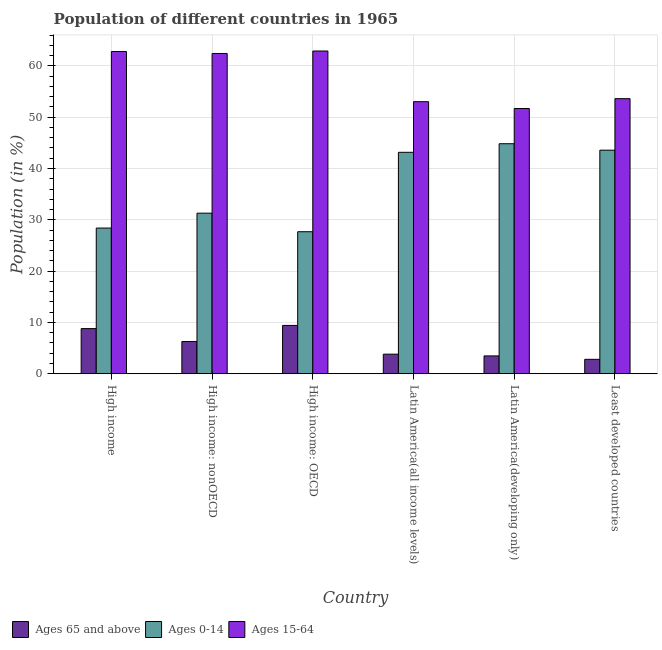How many different coloured bars are there?
Your answer should be compact. 3. Are the number of bars per tick equal to the number of legend labels?
Ensure brevity in your answer.  Yes. How many bars are there on the 6th tick from the left?
Ensure brevity in your answer.  3. What is the label of the 3rd group of bars from the left?
Your answer should be very brief. High income: OECD. In how many cases, is the number of bars for a given country not equal to the number of legend labels?
Keep it short and to the point. 0. What is the percentage of population within the age-group 0-14 in Latin America(all income levels)?
Give a very brief answer. 43.16. Across all countries, what is the maximum percentage of population within the age-group 0-14?
Provide a short and direct response. 44.83. Across all countries, what is the minimum percentage of population within the age-group 0-14?
Ensure brevity in your answer.  27.68. In which country was the percentage of population within the age-group 0-14 maximum?
Give a very brief answer. Latin America(developing only). In which country was the percentage of population within the age-group 0-14 minimum?
Your answer should be compact. High income: OECD. What is the total percentage of population within the age-group 0-14 in the graph?
Your answer should be compact. 218.94. What is the difference between the percentage of population within the age-group 0-14 in High income: OECD and that in High income: nonOECD?
Give a very brief answer. -3.62. What is the difference between the percentage of population within the age-group 0-14 in Latin America(developing only) and the percentage of population within the age-group 15-64 in High income?
Your answer should be compact. -17.98. What is the average percentage of population within the age-group 0-14 per country?
Offer a very short reply. 36.49. What is the difference between the percentage of population within the age-group 0-14 and percentage of population within the age-group of 65 and above in High income?
Ensure brevity in your answer.  19.6. What is the ratio of the percentage of population within the age-group of 65 and above in High income to that in Least developed countries?
Offer a very short reply. 3.13. Is the percentage of population within the age-group 15-64 in High income: OECD less than that in High income: nonOECD?
Provide a succinct answer. No. What is the difference between the highest and the second highest percentage of population within the age-group of 65 and above?
Make the answer very short. 0.62. What is the difference between the highest and the lowest percentage of population within the age-group 15-64?
Keep it short and to the point. 11.21. Is the sum of the percentage of population within the age-group of 65 and above in High income: OECD and Latin America(all income levels) greater than the maximum percentage of population within the age-group 0-14 across all countries?
Provide a short and direct response. No. What does the 3rd bar from the left in High income: OECD represents?
Offer a very short reply. Ages 15-64. What does the 2nd bar from the right in Latin America(developing only) represents?
Make the answer very short. Ages 0-14. How many bars are there?
Give a very brief answer. 18. Are all the bars in the graph horizontal?
Your answer should be compact. No. How many countries are there in the graph?
Offer a very short reply. 6. What is the difference between two consecutive major ticks on the Y-axis?
Offer a terse response. 10. Does the graph contain grids?
Ensure brevity in your answer.  Yes. How many legend labels are there?
Provide a short and direct response. 3. What is the title of the graph?
Make the answer very short. Population of different countries in 1965. What is the label or title of the X-axis?
Your answer should be compact. Country. What is the Population (in %) in Ages 65 and above in High income?
Give a very brief answer. 8.8. What is the Population (in %) in Ages 0-14 in High income?
Provide a short and direct response. 28.4. What is the Population (in %) in Ages 15-64 in High income?
Keep it short and to the point. 62.81. What is the Population (in %) of Ages 65 and above in High income: nonOECD?
Keep it short and to the point. 6.28. What is the Population (in %) in Ages 0-14 in High income: nonOECD?
Your answer should be very brief. 31.3. What is the Population (in %) in Ages 15-64 in High income: nonOECD?
Give a very brief answer. 62.42. What is the Population (in %) of Ages 65 and above in High income: OECD?
Keep it short and to the point. 9.42. What is the Population (in %) in Ages 0-14 in High income: OECD?
Your response must be concise. 27.68. What is the Population (in %) in Ages 15-64 in High income: OECD?
Offer a very short reply. 62.9. What is the Population (in %) in Ages 65 and above in Latin America(all income levels)?
Your answer should be very brief. 3.82. What is the Population (in %) of Ages 0-14 in Latin America(all income levels)?
Offer a terse response. 43.16. What is the Population (in %) of Ages 15-64 in Latin America(all income levels)?
Give a very brief answer. 53.03. What is the Population (in %) of Ages 65 and above in Latin America(developing only)?
Offer a terse response. 3.47. What is the Population (in %) in Ages 0-14 in Latin America(developing only)?
Offer a terse response. 44.83. What is the Population (in %) of Ages 15-64 in Latin America(developing only)?
Provide a succinct answer. 51.7. What is the Population (in %) in Ages 65 and above in Least developed countries?
Provide a succinct answer. 2.81. What is the Population (in %) of Ages 0-14 in Least developed countries?
Provide a succinct answer. 43.57. What is the Population (in %) of Ages 15-64 in Least developed countries?
Offer a terse response. 53.61. Across all countries, what is the maximum Population (in %) of Ages 65 and above?
Your answer should be very brief. 9.42. Across all countries, what is the maximum Population (in %) of Ages 0-14?
Give a very brief answer. 44.83. Across all countries, what is the maximum Population (in %) of Ages 15-64?
Provide a succinct answer. 62.9. Across all countries, what is the minimum Population (in %) of Ages 65 and above?
Keep it short and to the point. 2.81. Across all countries, what is the minimum Population (in %) in Ages 0-14?
Make the answer very short. 27.68. Across all countries, what is the minimum Population (in %) of Ages 15-64?
Your answer should be compact. 51.7. What is the total Population (in %) of Ages 65 and above in the graph?
Make the answer very short. 34.6. What is the total Population (in %) in Ages 0-14 in the graph?
Your answer should be very brief. 218.94. What is the total Population (in %) in Ages 15-64 in the graph?
Your answer should be compact. 346.47. What is the difference between the Population (in %) of Ages 65 and above in High income and that in High income: nonOECD?
Your response must be concise. 2.52. What is the difference between the Population (in %) in Ages 0-14 in High income and that in High income: nonOECD?
Offer a very short reply. -2.9. What is the difference between the Population (in %) of Ages 15-64 in High income and that in High income: nonOECD?
Offer a very short reply. 0.39. What is the difference between the Population (in %) of Ages 65 and above in High income and that in High income: OECD?
Give a very brief answer. -0.62. What is the difference between the Population (in %) in Ages 0-14 in High income and that in High income: OECD?
Provide a short and direct response. 0.72. What is the difference between the Population (in %) of Ages 15-64 in High income and that in High income: OECD?
Give a very brief answer. -0.1. What is the difference between the Population (in %) in Ages 65 and above in High income and that in Latin America(all income levels)?
Keep it short and to the point. 4.98. What is the difference between the Population (in %) of Ages 0-14 in High income and that in Latin America(all income levels)?
Make the answer very short. -14.76. What is the difference between the Population (in %) of Ages 15-64 in High income and that in Latin America(all income levels)?
Ensure brevity in your answer.  9.78. What is the difference between the Population (in %) of Ages 65 and above in High income and that in Latin America(developing only)?
Provide a short and direct response. 5.32. What is the difference between the Population (in %) of Ages 0-14 in High income and that in Latin America(developing only)?
Make the answer very short. -16.44. What is the difference between the Population (in %) of Ages 15-64 in High income and that in Latin America(developing only)?
Your answer should be very brief. 11.11. What is the difference between the Population (in %) of Ages 65 and above in High income and that in Least developed countries?
Your response must be concise. 5.99. What is the difference between the Population (in %) of Ages 0-14 in High income and that in Least developed countries?
Provide a short and direct response. -15.18. What is the difference between the Population (in %) in Ages 15-64 in High income and that in Least developed countries?
Offer a very short reply. 9.19. What is the difference between the Population (in %) in Ages 65 and above in High income: nonOECD and that in High income: OECD?
Offer a terse response. -3.14. What is the difference between the Population (in %) of Ages 0-14 in High income: nonOECD and that in High income: OECD?
Provide a succinct answer. 3.62. What is the difference between the Population (in %) of Ages 15-64 in High income: nonOECD and that in High income: OECD?
Provide a succinct answer. -0.48. What is the difference between the Population (in %) of Ages 65 and above in High income: nonOECD and that in Latin America(all income levels)?
Your answer should be compact. 2.46. What is the difference between the Population (in %) in Ages 0-14 in High income: nonOECD and that in Latin America(all income levels)?
Your response must be concise. -11.86. What is the difference between the Population (in %) of Ages 15-64 in High income: nonOECD and that in Latin America(all income levels)?
Your response must be concise. 9.4. What is the difference between the Population (in %) in Ages 65 and above in High income: nonOECD and that in Latin America(developing only)?
Offer a terse response. 2.81. What is the difference between the Population (in %) in Ages 0-14 in High income: nonOECD and that in Latin America(developing only)?
Your answer should be compact. -13.53. What is the difference between the Population (in %) in Ages 15-64 in High income: nonOECD and that in Latin America(developing only)?
Offer a terse response. 10.73. What is the difference between the Population (in %) in Ages 65 and above in High income: nonOECD and that in Least developed countries?
Provide a succinct answer. 3.47. What is the difference between the Population (in %) of Ages 0-14 in High income: nonOECD and that in Least developed countries?
Provide a succinct answer. -12.28. What is the difference between the Population (in %) in Ages 15-64 in High income: nonOECD and that in Least developed countries?
Offer a terse response. 8.81. What is the difference between the Population (in %) of Ages 65 and above in High income: OECD and that in Latin America(all income levels)?
Your answer should be compact. 5.6. What is the difference between the Population (in %) of Ages 0-14 in High income: OECD and that in Latin America(all income levels)?
Provide a succinct answer. -15.48. What is the difference between the Population (in %) in Ages 15-64 in High income: OECD and that in Latin America(all income levels)?
Give a very brief answer. 9.88. What is the difference between the Population (in %) in Ages 65 and above in High income: OECD and that in Latin America(developing only)?
Your response must be concise. 5.95. What is the difference between the Population (in %) of Ages 0-14 in High income: OECD and that in Latin America(developing only)?
Give a very brief answer. -17.15. What is the difference between the Population (in %) of Ages 15-64 in High income: OECD and that in Latin America(developing only)?
Give a very brief answer. 11.21. What is the difference between the Population (in %) of Ages 65 and above in High income: OECD and that in Least developed countries?
Your response must be concise. 6.61. What is the difference between the Population (in %) of Ages 0-14 in High income: OECD and that in Least developed countries?
Provide a short and direct response. -15.89. What is the difference between the Population (in %) of Ages 15-64 in High income: OECD and that in Least developed countries?
Keep it short and to the point. 9.29. What is the difference between the Population (in %) in Ages 65 and above in Latin America(all income levels) and that in Latin America(developing only)?
Your answer should be compact. 0.34. What is the difference between the Population (in %) in Ages 0-14 in Latin America(all income levels) and that in Latin America(developing only)?
Keep it short and to the point. -1.67. What is the difference between the Population (in %) of Ages 15-64 in Latin America(all income levels) and that in Latin America(developing only)?
Your answer should be very brief. 1.33. What is the difference between the Population (in %) of Ages 65 and above in Latin America(all income levels) and that in Least developed countries?
Keep it short and to the point. 1.01. What is the difference between the Population (in %) of Ages 0-14 in Latin America(all income levels) and that in Least developed countries?
Provide a succinct answer. -0.42. What is the difference between the Population (in %) of Ages 15-64 in Latin America(all income levels) and that in Least developed countries?
Ensure brevity in your answer.  -0.59. What is the difference between the Population (in %) of Ages 65 and above in Latin America(developing only) and that in Least developed countries?
Offer a very short reply. 0.66. What is the difference between the Population (in %) in Ages 0-14 in Latin America(developing only) and that in Least developed countries?
Ensure brevity in your answer.  1.26. What is the difference between the Population (in %) in Ages 15-64 in Latin America(developing only) and that in Least developed countries?
Provide a succinct answer. -1.92. What is the difference between the Population (in %) in Ages 65 and above in High income and the Population (in %) in Ages 0-14 in High income: nonOECD?
Provide a succinct answer. -22.5. What is the difference between the Population (in %) of Ages 65 and above in High income and the Population (in %) of Ages 15-64 in High income: nonOECD?
Make the answer very short. -53.62. What is the difference between the Population (in %) of Ages 0-14 in High income and the Population (in %) of Ages 15-64 in High income: nonOECD?
Provide a short and direct response. -34.03. What is the difference between the Population (in %) in Ages 65 and above in High income and the Population (in %) in Ages 0-14 in High income: OECD?
Ensure brevity in your answer.  -18.88. What is the difference between the Population (in %) of Ages 65 and above in High income and the Population (in %) of Ages 15-64 in High income: OECD?
Ensure brevity in your answer.  -54.1. What is the difference between the Population (in %) of Ages 0-14 in High income and the Population (in %) of Ages 15-64 in High income: OECD?
Make the answer very short. -34.51. What is the difference between the Population (in %) in Ages 65 and above in High income and the Population (in %) in Ages 0-14 in Latin America(all income levels)?
Your answer should be very brief. -34.36. What is the difference between the Population (in %) of Ages 65 and above in High income and the Population (in %) of Ages 15-64 in Latin America(all income levels)?
Provide a succinct answer. -44.23. What is the difference between the Population (in %) of Ages 0-14 in High income and the Population (in %) of Ages 15-64 in Latin America(all income levels)?
Your answer should be compact. -24.63. What is the difference between the Population (in %) in Ages 65 and above in High income and the Population (in %) in Ages 0-14 in Latin America(developing only)?
Give a very brief answer. -36.03. What is the difference between the Population (in %) in Ages 65 and above in High income and the Population (in %) in Ages 15-64 in Latin America(developing only)?
Your response must be concise. -42.9. What is the difference between the Population (in %) in Ages 0-14 in High income and the Population (in %) in Ages 15-64 in Latin America(developing only)?
Provide a short and direct response. -23.3. What is the difference between the Population (in %) in Ages 65 and above in High income and the Population (in %) in Ages 0-14 in Least developed countries?
Provide a short and direct response. -34.78. What is the difference between the Population (in %) in Ages 65 and above in High income and the Population (in %) in Ages 15-64 in Least developed countries?
Offer a very short reply. -44.82. What is the difference between the Population (in %) of Ages 0-14 in High income and the Population (in %) of Ages 15-64 in Least developed countries?
Provide a short and direct response. -25.22. What is the difference between the Population (in %) in Ages 65 and above in High income: nonOECD and the Population (in %) in Ages 0-14 in High income: OECD?
Keep it short and to the point. -21.4. What is the difference between the Population (in %) in Ages 65 and above in High income: nonOECD and the Population (in %) in Ages 15-64 in High income: OECD?
Provide a short and direct response. -56.62. What is the difference between the Population (in %) in Ages 0-14 in High income: nonOECD and the Population (in %) in Ages 15-64 in High income: OECD?
Ensure brevity in your answer.  -31.6. What is the difference between the Population (in %) in Ages 65 and above in High income: nonOECD and the Population (in %) in Ages 0-14 in Latin America(all income levels)?
Keep it short and to the point. -36.88. What is the difference between the Population (in %) in Ages 65 and above in High income: nonOECD and the Population (in %) in Ages 15-64 in Latin America(all income levels)?
Provide a short and direct response. -46.74. What is the difference between the Population (in %) of Ages 0-14 in High income: nonOECD and the Population (in %) of Ages 15-64 in Latin America(all income levels)?
Provide a succinct answer. -21.73. What is the difference between the Population (in %) in Ages 65 and above in High income: nonOECD and the Population (in %) in Ages 0-14 in Latin America(developing only)?
Offer a terse response. -38.55. What is the difference between the Population (in %) in Ages 65 and above in High income: nonOECD and the Population (in %) in Ages 15-64 in Latin America(developing only)?
Offer a very short reply. -45.41. What is the difference between the Population (in %) of Ages 0-14 in High income: nonOECD and the Population (in %) of Ages 15-64 in Latin America(developing only)?
Keep it short and to the point. -20.4. What is the difference between the Population (in %) of Ages 65 and above in High income: nonOECD and the Population (in %) of Ages 0-14 in Least developed countries?
Offer a very short reply. -37.29. What is the difference between the Population (in %) of Ages 65 and above in High income: nonOECD and the Population (in %) of Ages 15-64 in Least developed countries?
Provide a short and direct response. -47.33. What is the difference between the Population (in %) in Ages 0-14 in High income: nonOECD and the Population (in %) in Ages 15-64 in Least developed countries?
Ensure brevity in your answer.  -22.32. What is the difference between the Population (in %) in Ages 65 and above in High income: OECD and the Population (in %) in Ages 0-14 in Latin America(all income levels)?
Provide a short and direct response. -33.74. What is the difference between the Population (in %) in Ages 65 and above in High income: OECD and the Population (in %) in Ages 15-64 in Latin America(all income levels)?
Keep it short and to the point. -43.61. What is the difference between the Population (in %) of Ages 0-14 in High income: OECD and the Population (in %) of Ages 15-64 in Latin America(all income levels)?
Make the answer very short. -25.35. What is the difference between the Population (in %) of Ages 65 and above in High income: OECD and the Population (in %) of Ages 0-14 in Latin America(developing only)?
Your answer should be very brief. -35.41. What is the difference between the Population (in %) of Ages 65 and above in High income: OECD and the Population (in %) of Ages 15-64 in Latin America(developing only)?
Keep it short and to the point. -42.28. What is the difference between the Population (in %) in Ages 0-14 in High income: OECD and the Population (in %) in Ages 15-64 in Latin America(developing only)?
Provide a short and direct response. -24.02. What is the difference between the Population (in %) in Ages 65 and above in High income: OECD and the Population (in %) in Ages 0-14 in Least developed countries?
Give a very brief answer. -34.16. What is the difference between the Population (in %) of Ages 65 and above in High income: OECD and the Population (in %) of Ages 15-64 in Least developed countries?
Your answer should be compact. -44.2. What is the difference between the Population (in %) in Ages 0-14 in High income: OECD and the Population (in %) in Ages 15-64 in Least developed countries?
Give a very brief answer. -25.94. What is the difference between the Population (in %) of Ages 65 and above in Latin America(all income levels) and the Population (in %) of Ages 0-14 in Latin America(developing only)?
Provide a short and direct response. -41.01. What is the difference between the Population (in %) in Ages 65 and above in Latin America(all income levels) and the Population (in %) in Ages 15-64 in Latin America(developing only)?
Ensure brevity in your answer.  -47.88. What is the difference between the Population (in %) of Ages 0-14 in Latin America(all income levels) and the Population (in %) of Ages 15-64 in Latin America(developing only)?
Keep it short and to the point. -8.54. What is the difference between the Population (in %) of Ages 65 and above in Latin America(all income levels) and the Population (in %) of Ages 0-14 in Least developed countries?
Your answer should be compact. -39.76. What is the difference between the Population (in %) in Ages 65 and above in Latin America(all income levels) and the Population (in %) in Ages 15-64 in Least developed countries?
Offer a terse response. -49.8. What is the difference between the Population (in %) in Ages 0-14 in Latin America(all income levels) and the Population (in %) in Ages 15-64 in Least developed countries?
Provide a short and direct response. -10.46. What is the difference between the Population (in %) of Ages 65 and above in Latin America(developing only) and the Population (in %) of Ages 0-14 in Least developed countries?
Your answer should be very brief. -40.1. What is the difference between the Population (in %) in Ages 65 and above in Latin America(developing only) and the Population (in %) in Ages 15-64 in Least developed countries?
Offer a very short reply. -50.14. What is the difference between the Population (in %) in Ages 0-14 in Latin America(developing only) and the Population (in %) in Ages 15-64 in Least developed countries?
Make the answer very short. -8.78. What is the average Population (in %) in Ages 65 and above per country?
Offer a terse response. 5.77. What is the average Population (in %) in Ages 0-14 per country?
Offer a terse response. 36.49. What is the average Population (in %) in Ages 15-64 per country?
Your answer should be compact. 57.74. What is the difference between the Population (in %) of Ages 65 and above and Population (in %) of Ages 0-14 in High income?
Provide a succinct answer. -19.6. What is the difference between the Population (in %) in Ages 65 and above and Population (in %) in Ages 15-64 in High income?
Your response must be concise. -54.01. What is the difference between the Population (in %) of Ages 0-14 and Population (in %) of Ages 15-64 in High income?
Ensure brevity in your answer.  -34.41. What is the difference between the Population (in %) of Ages 65 and above and Population (in %) of Ages 0-14 in High income: nonOECD?
Make the answer very short. -25.02. What is the difference between the Population (in %) of Ages 65 and above and Population (in %) of Ages 15-64 in High income: nonOECD?
Your answer should be compact. -56.14. What is the difference between the Population (in %) of Ages 0-14 and Population (in %) of Ages 15-64 in High income: nonOECD?
Your response must be concise. -31.12. What is the difference between the Population (in %) in Ages 65 and above and Population (in %) in Ages 0-14 in High income: OECD?
Your answer should be compact. -18.26. What is the difference between the Population (in %) of Ages 65 and above and Population (in %) of Ages 15-64 in High income: OECD?
Make the answer very short. -53.48. What is the difference between the Population (in %) of Ages 0-14 and Population (in %) of Ages 15-64 in High income: OECD?
Your answer should be very brief. -35.22. What is the difference between the Population (in %) of Ages 65 and above and Population (in %) of Ages 0-14 in Latin America(all income levels)?
Your response must be concise. -39.34. What is the difference between the Population (in %) of Ages 65 and above and Population (in %) of Ages 15-64 in Latin America(all income levels)?
Offer a very short reply. -49.21. What is the difference between the Population (in %) of Ages 0-14 and Population (in %) of Ages 15-64 in Latin America(all income levels)?
Offer a terse response. -9.87. What is the difference between the Population (in %) of Ages 65 and above and Population (in %) of Ages 0-14 in Latin America(developing only)?
Your response must be concise. -41.36. What is the difference between the Population (in %) in Ages 65 and above and Population (in %) in Ages 15-64 in Latin America(developing only)?
Keep it short and to the point. -48.22. What is the difference between the Population (in %) of Ages 0-14 and Population (in %) of Ages 15-64 in Latin America(developing only)?
Ensure brevity in your answer.  -6.86. What is the difference between the Population (in %) in Ages 65 and above and Population (in %) in Ages 0-14 in Least developed countries?
Your answer should be compact. -40.76. What is the difference between the Population (in %) in Ages 65 and above and Population (in %) in Ages 15-64 in Least developed countries?
Your response must be concise. -50.8. What is the difference between the Population (in %) of Ages 0-14 and Population (in %) of Ages 15-64 in Least developed countries?
Your answer should be very brief. -10.04. What is the ratio of the Population (in %) of Ages 65 and above in High income to that in High income: nonOECD?
Provide a succinct answer. 1.4. What is the ratio of the Population (in %) of Ages 0-14 in High income to that in High income: nonOECD?
Provide a succinct answer. 0.91. What is the ratio of the Population (in %) in Ages 65 and above in High income to that in High income: OECD?
Provide a short and direct response. 0.93. What is the ratio of the Population (in %) in Ages 0-14 in High income to that in High income: OECD?
Provide a succinct answer. 1.03. What is the ratio of the Population (in %) in Ages 15-64 in High income to that in High income: OECD?
Keep it short and to the point. 1. What is the ratio of the Population (in %) of Ages 65 and above in High income to that in Latin America(all income levels)?
Give a very brief answer. 2.31. What is the ratio of the Population (in %) in Ages 0-14 in High income to that in Latin America(all income levels)?
Offer a terse response. 0.66. What is the ratio of the Population (in %) in Ages 15-64 in High income to that in Latin America(all income levels)?
Keep it short and to the point. 1.18. What is the ratio of the Population (in %) of Ages 65 and above in High income to that in Latin America(developing only)?
Your answer should be very brief. 2.53. What is the ratio of the Population (in %) of Ages 0-14 in High income to that in Latin America(developing only)?
Your answer should be very brief. 0.63. What is the ratio of the Population (in %) of Ages 15-64 in High income to that in Latin America(developing only)?
Your response must be concise. 1.21. What is the ratio of the Population (in %) in Ages 65 and above in High income to that in Least developed countries?
Offer a terse response. 3.13. What is the ratio of the Population (in %) in Ages 0-14 in High income to that in Least developed countries?
Offer a very short reply. 0.65. What is the ratio of the Population (in %) of Ages 15-64 in High income to that in Least developed countries?
Offer a very short reply. 1.17. What is the ratio of the Population (in %) in Ages 65 and above in High income: nonOECD to that in High income: OECD?
Your response must be concise. 0.67. What is the ratio of the Population (in %) in Ages 0-14 in High income: nonOECD to that in High income: OECD?
Give a very brief answer. 1.13. What is the ratio of the Population (in %) in Ages 65 and above in High income: nonOECD to that in Latin America(all income levels)?
Provide a succinct answer. 1.65. What is the ratio of the Population (in %) in Ages 0-14 in High income: nonOECD to that in Latin America(all income levels)?
Your answer should be compact. 0.73. What is the ratio of the Population (in %) in Ages 15-64 in High income: nonOECD to that in Latin America(all income levels)?
Your answer should be compact. 1.18. What is the ratio of the Population (in %) in Ages 65 and above in High income: nonOECD to that in Latin America(developing only)?
Give a very brief answer. 1.81. What is the ratio of the Population (in %) in Ages 0-14 in High income: nonOECD to that in Latin America(developing only)?
Provide a succinct answer. 0.7. What is the ratio of the Population (in %) in Ages 15-64 in High income: nonOECD to that in Latin America(developing only)?
Your answer should be compact. 1.21. What is the ratio of the Population (in %) of Ages 65 and above in High income: nonOECD to that in Least developed countries?
Offer a terse response. 2.23. What is the ratio of the Population (in %) of Ages 0-14 in High income: nonOECD to that in Least developed countries?
Make the answer very short. 0.72. What is the ratio of the Population (in %) of Ages 15-64 in High income: nonOECD to that in Least developed countries?
Your answer should be compact. 1.16. What is the ratio of the Population (in %) in Ages 65 and above in High income: OECD to that in Latin America(all income levels)?
Offer a terse response. 2.47. What is the ratio of the Population (in %) of Ages 0-14 in High income: OECD to that in Latin America(all income levels)?
Your response must be concise. 0.64. What is the ratio of the Population (in %) of Ages 15-64 in High income: OECD to that in Latin America(all income levels)?
Provide a short and direct response. 1.19. What is the ratio of the Population (in %) in Ages 65 and above in High income: OECD to that in Latin America(developing only)?
Make the answer very short. 2.71. What is the ratio of the Population (in %) of Ages 0-14 in High income: OECD to that in Latin America(developing only)?
Your answer should be very brief. 0.62. What is the ratio of the Population (in %) in Ages 15-64 in High income: OECD to that in Latin America(developing only)?
Give a very brief answer. 1.22. What is the ratio of the Population (in %) of Ages 65 and above in High income: OECD to that in Least developed countries?
Your answer should be very brief. 3.35. What is the ratio of the Population (in %) in Ages 0-14 in High income: OECD to that in Least developed countries?
Your answer should be very brief. 0.64. What is the ratio of the Population (in %) of Ages 15-64 in High income: OECD to that in Least developed countries?
Ensure brevity in your answer.  1.17. What is the ratio of the Population (in %) in Ages 65 and above in Latin America(all income levels) to that in Latin America(developing only)?
Provide a short and direct response. 1.1. What is the ratio of the Population (in %) of Ages 0-14 in Latin America(all income levels) to that in Latin America(developing only)?
Your answer should be very brief. 0.96. What is the ratio of the Population (in %) in Ages 15-64 in Latin America(all income levels) to that in Latin America(developing only)?
Make the answer very short. 1.03. What is the ratio of the Population (in %) of Ages 65 and above in Latin America(all income levels) to that in Least developed countries?
Give a very brief answer. 1.36. What is the ratio of the Population (in %) in Ages 15-64 in Latin America(all income levels) to that in Least developed countries?
Offer a very short reply. 0.99. What is the ratio of the Population (in %) in Ages 65 and above in Latin America(developing only) to that in Least developed countries?
Your response must be concise. 1.24. What is the ratio of the Population (in %) in Ages 0-14 in Latin America(developing only) to that in Least developed countries?
Your answer should be very brief. 1.03. What is the ratio of the Population (in %) of Ages 15-64 in Latin America(developing only) to that in Least developed countries?
Keep it short and to the point. 0.96. What is the difference between the highest and the second highest Population (in %) in Ages 65 and above?
Make the answer very short. 0.62. What is the difference between the highest and the second highest Population (in %) in Ages 0-14?
Your response must be concise. 1.26. What is the difference between the highest and the second highest Population (in %) in Ages 15-64?
Ensure brevity in your answer.  0.1. What is the difference between the highest and the lowest Population (in %) in Ages 65 and above?
Your answer should be compact. 6.61. What is the difference between the highest and the lowest Population (in %) of Ages 0-14?
Offer a terse response. 17.15. What is the difference between the highest and the lowest Population (in %) in Ages 15-64?
Give a very brief answer. 11.21. 